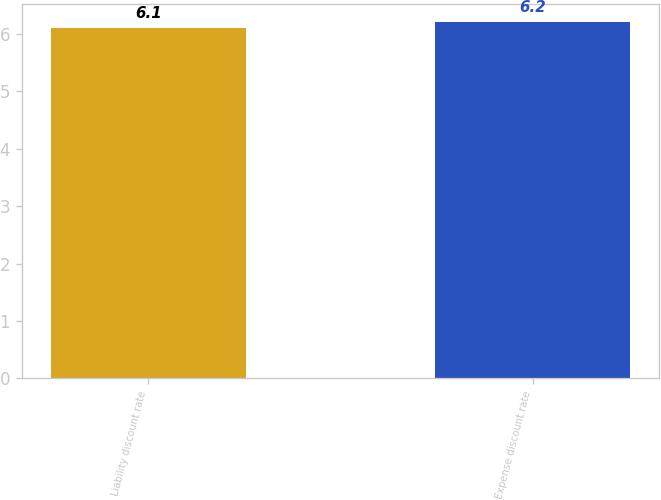<chart> <loc_0><loc_0><loc_500><loc_500><bar_chart><fcel>Liability discount rate<fcel>Expense discount rate<nl><fcel>6.1<fcel>6.2<nl></chart> 